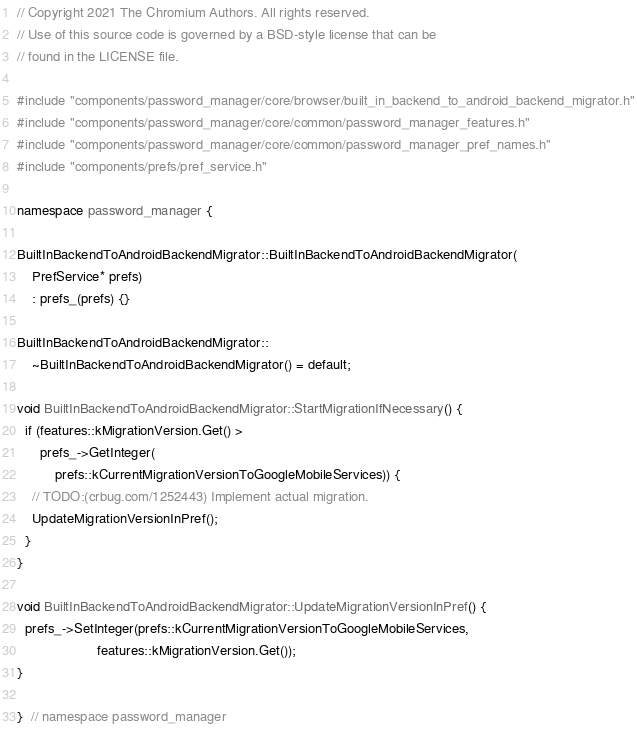<code> <loc_0><loc_0><loc_500><loc_500><_C++_>// Copyright 2021 The Chromium Authors. All rights reserved.
// Use of this source code is governed by a BSD-style license that can be
// found in the LICENSE file.

#include "components/password_manager/core/browser/built_in_backend_to_android_backend_migrator.h"
#include "components/password_manager/core/common/password_manager_features.h"
#include "components/password_manager/core/common/password_manager_pref_names.h"
#include "components/prefs/pref_service.h"

namespace password_manager {

BuiltInBackendToAndroidBackendMigrator::BuiltInBackendToAndroidBackendMigrator(
    PrefService* prefs)
    : prefs_(prefs) {}

BuiltInBackendToAndroidBackendMigrator::
    ~BuiltInBackendToAndroidBackendMigrator() = default;

void BuiltInBackendToAndroidBackendMigrator::StartMigrationIfNecessary() {
  if (features::kMigrationVersion.Get() >
      prefs_->GetInteger(
          prefs::kCurrentMigrationVersionToGoogleMobileServices)) {
    // TODO:(crbug.com/1252443) Implement actual migration.
    UpdateMigrationVersionInPref();
  }
}

void BuiltInBackendToAndroidBackendMigrator::UpdateMigrationVersionInPref() {
  prefs_->SetInteger(prefs::kCurrentMigrationVersionToGoogleMobileServices,
                     features::kMigrationVersion.Get());
}

}  // namespace password_manager
</code> 